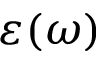Convert formula to latex. <formula><loc_0><loc_0><loc_500><loc_500>\varepsilon ( \omega )</formula> 